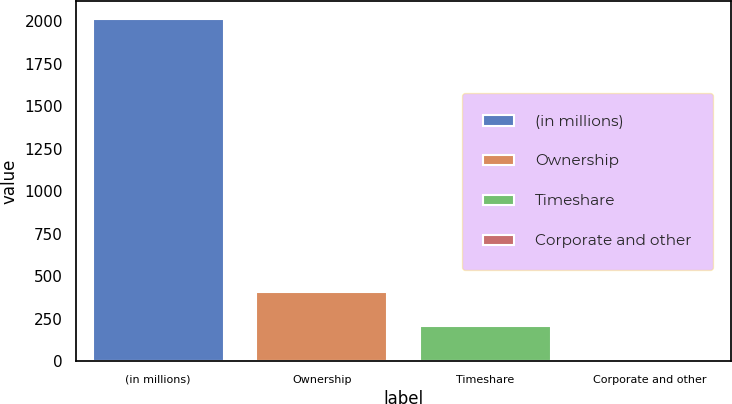Convert chart to OTSL. <chart><loc_0><loc_0><loc_500><loc_500><bar_chart><fcel>(in millions)<fcel>Ownership<fcel>Timeshare<fcel>Corporate and other<nl><fcel>2014<fcel>410<fcel>209.5<fcel>9<nl></chart> 